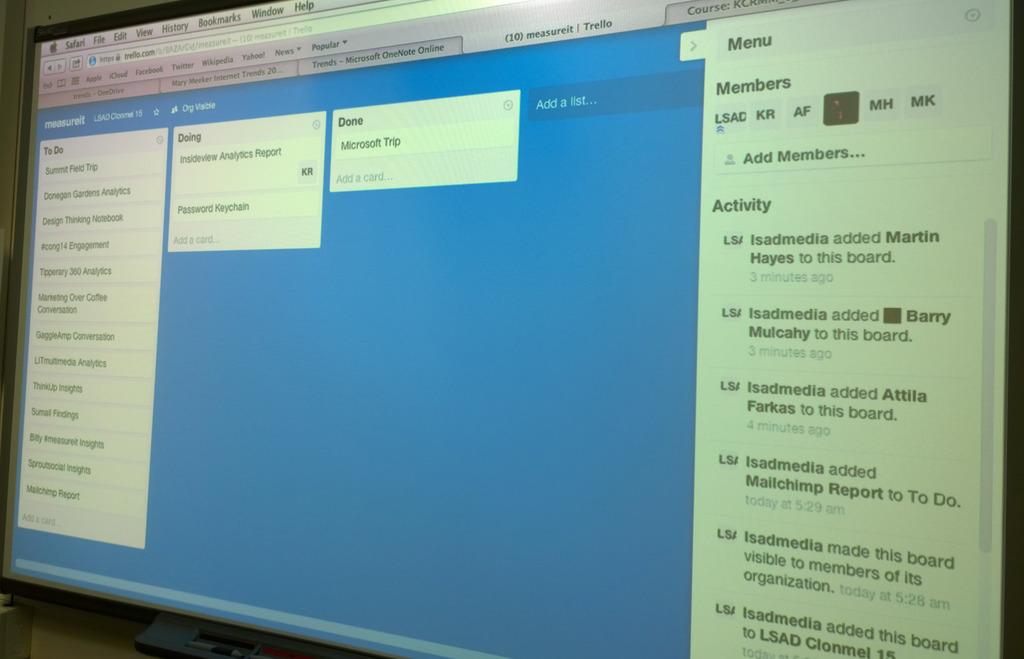What does the top activity say?
Ensure brevity in your answer.  Unanswerable. What is on the right at the top?
Your answer should be compact. Menu. 